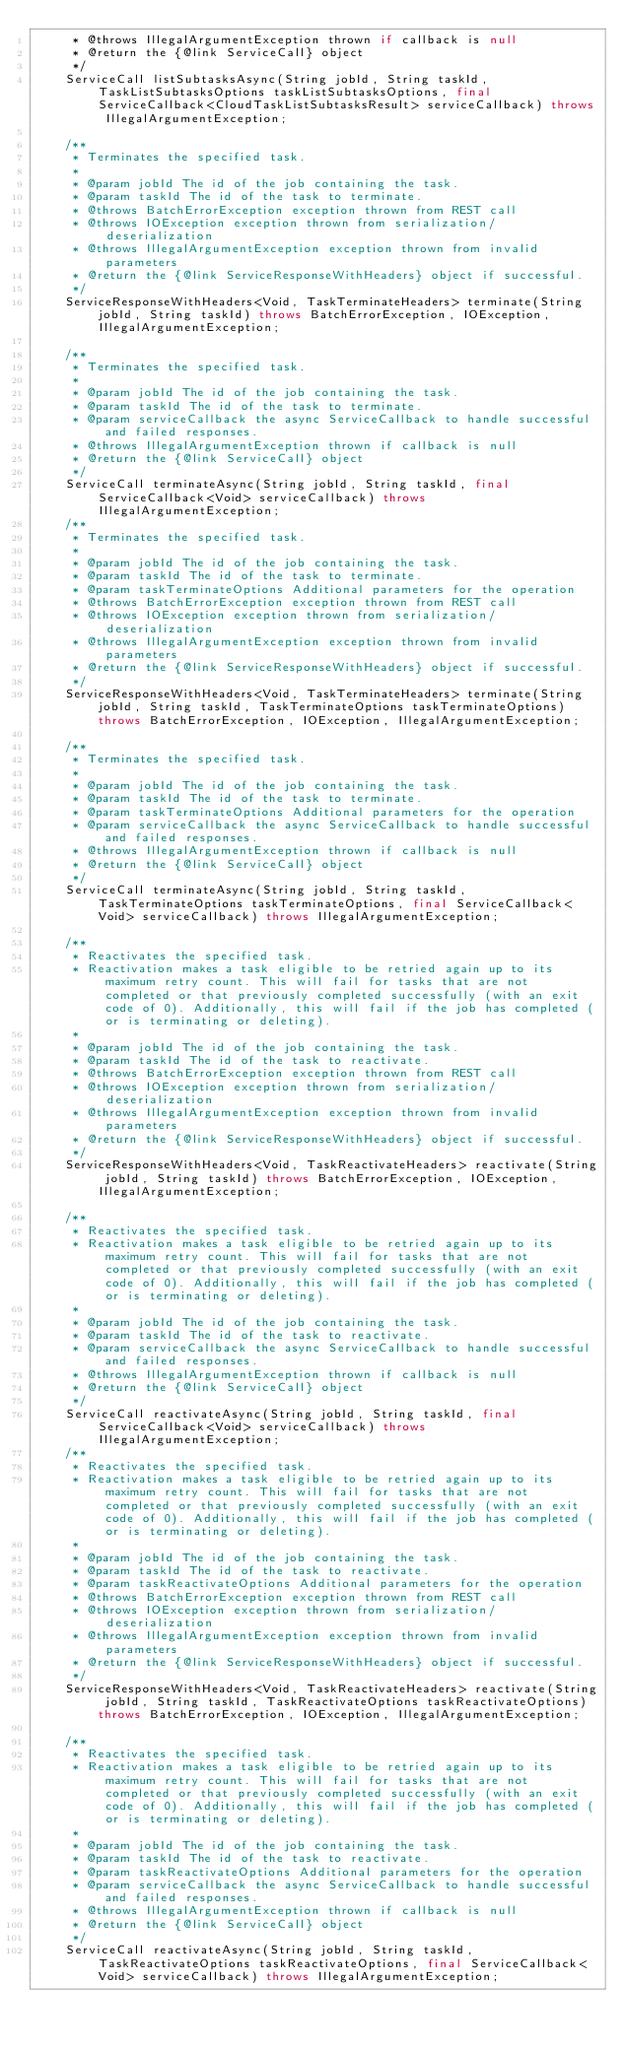<code> <loc_0><loc_0><loc_500><loc_500><_Java_>     * @throws IllegalArgumentException thrown if callback is null
     * @return the {@link ServiceCall} object
     */
    ServiceCall listSubtasksAsync(String jobId, String taskId, TaskListSubtasksOptions taskListSubtasksOptions, final ServiceCallback<CloudTaskListSubtasksResult> serviceCallback) throws IllegalArgumentException;

    /**
     * Terminates the specified task.
     *
     * @param jobId The id of the job containing the task.
     * @param taskId The id of the task to terminate.
     * @throws BatchErrorException exception thrown from REST call
     * @throws IOException exception thrown from serialization/deserialization
     * @throws IllegalArgumentException exception thrown from invalid parameters
     * @return the {@link ServiceResponseWithHeaders} object if successful.
     */
    ServiceResponseWithHeaders<Void, TaskTerminateHeaders> terminate(String jobId, String taskId) throws BatchErrorException, IOException, IllegalArgumentException;

    /**
     * Terminates the specified task.
     *
     * @param jobId The id of the job containing the task.
     * @param taskId The id of the task to terminate.
     * @param serviceCallback the async ServiceCallback to handle successful and failed responses.
     * @throws IllegalArgumentException thrown if callback is null
     * @return the {@link ServiceCall} object
     */
    ServiceCall terminateAsync(String jobId, String taskId, final ServiceCallback<Void> serviceCallback) throws IllegalArgumentException;
    /**
     * Terminates the specified task.
     *
     * @param jobId The id of the job containing the task.
     * @param taskId The id of the task to terminate.
     * @param taskTerminateOptions Additional parameters for the operation
     * @throws BatchErrorException exception thrown from REST call
     * @throws IOException exception thrown from serialization/deserialization
     * @throws IllegalArgumentException exception thrown from invalid parameters
     * @return the {@link ServiceResponseWithHeaders} object if successful.
     */
    ServiceResponseWithHeaders<Void, TaskTerminateHeaders> terminate(String jobId, String taskId, TaskTerminateOptions taskTerminateOptions) throws BatchErrorException, IOException, IllegalArgumentException;

    /**
     * Terminates the specified task.
     *
     * @param jobId The id of the job containing the task.
     * @param taskId The id of the task to terminate.
     * @param taskTerminateOptions Additional parameters for the operation
     * @param serviceCallback the async ServiceCallback to handle successful and failed responses.
     * @throws IllegalArgumentException thrown if callback is null
     * @return the {@link ServiceCall} object
     */
    ServiceCall terminateAsync(String jobId, String taskId, TaskTerminateOptions taskTerminateOptions, final ServiceCallback<Void> serviceCallback) throws IllegalArgumentException;

    /**
     * Reactivates the specified task.
     * Reactivation makes a task eligible to be retried again up to its maximum retry count. This will fail for tasks that are not completed or that previously completed successfully (with an exit code of 0). Additionally, this will fail if the job has completed (or is terminating or deleting).
     *
     * @param jobId The id of the job containing the task.
     * @param taskId The id of the task to reactivate.
     * @throws BatchErrorException exception thrown from REST call
     * @throws IOException exception thrown from serialization/deserialization
     * @throws IllegalArgumentException exception thrown from invalid parameters
     * @return the {@link ServiceResponseWithHeaders} object if successful.
     */
    ServiceResponseWithHeaders<Void, TaskReactivateHeaders> reactivate(String jobId, String taskId) throws BatchErrorException, IOException, IllegalArgumentException;

    /**
     * Reactivates the specified task.
     * Reactivation makes a task eligible to be retried again up to its maximum retry count. This will fail for tasks that are not completed or that previously completed successfully (with an exit code of 0). Additionally, this will fail if the job has completed (or is terminating or deleting).
     *
     * @param jobId The id of the job containing the task.
     * @param taskId The id of the task to reactivate.
     * @param serviceCallback the async ServiceCallback to handle successful and failed responses.
     * @throws IllegalArgumentException thrown if callback is null
     * @return the {@link ServiceCall} object
     */
    ServiceCall reactivateAsync(String jobId, String taskId, final ServiceCallback<Void> serviceCallback) throws IllegalArgumentException;
    /**
     * Reactivates the specified task.
     * Reactivation makes a task eligible to be retried again up to its maximum retry count. This will fail for tasks that are not completed or that previously completed successfully (with an exit code of 0). Additionally, this will fail if the job has completed (or is terminating or deleting).
     *
     * @param jobId The id of the job containing the task.
     * @param taskId The id of the task to reactivate.
     * @param taskReactivateOptions Additional parameters for the operation
     * @throws BatchErrorException exception thrown from REST call
     * @throws IOException exception thrown from serialization/deserialization
     * @throws IllegalArgumentException exception thrown from invalid parameters
     * @return the {@link ServiceResponseWithHeaders} object if successful.
     */
    ServiceResponseWithHeaders<Void, TaskReactivateHeaders> reactivate(String jobId, String taskId, TaskReactivateOptions taskReactivateOptions) throws BatchErrorException, IOException, IllegalArgumentException;

    /**
     * Reactivates the specified task.
     * Reactivation makes a task eligible to be retried again up to its maximum retry count. This will fail for tasks that are not completed or that previously completed successfully (with an exit code of 0). Additionally, this will fail if the job has completed (or is terminating or deleting).
     *
     * @param jobId The id of the job containing the task.
     * @param taskId The id of the task to reactivate.
     * @param taskReactivateOptions Additional parameters for the operation
     * @param serviceCallback the async ServiceCallback to handle successful and failed responses.
     * @throws IllegalArgumentException thrown if callback is null
     * @return the {@link ServiceCall} object
     */
    ServiceCall reactivateAsync(String jobId, String taskId, TaskReactivateOptions taskReactivateOptions, final ServiceCallback<Void> serviceCallback) throws IllegalArgumentException;
</code> 